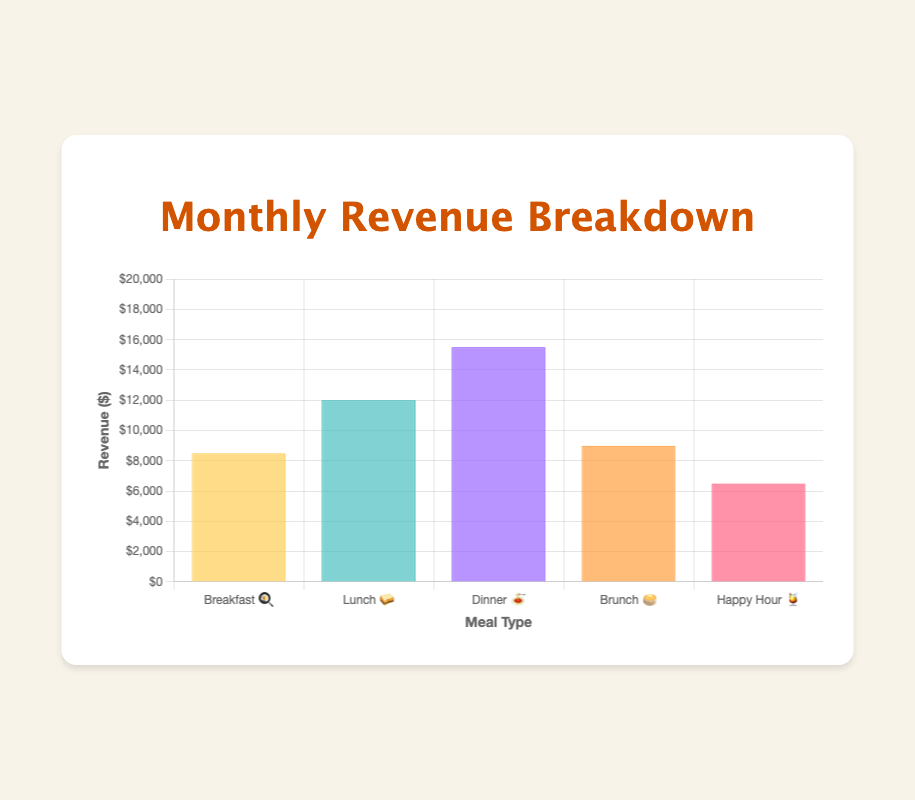What is the title of the chart? The title is at the top of the chart, and it states the main subject of the visualization.
Answer: Monthly Revenue Breakdown Which meal type generates the highest revenue? By looking at the height of the bars, the "Dinner 🍝" bar is the tallest.
Answer: Dinner 🍝 What is the total revenue from Breakfast 🍳 and Brunch 🥞 combined? Add the revenue from Breakfast 🍳 ($8500) and Brunch 🥞 ($9000): $8500 + $9000 = $17500
Answer: $17500 What is the difference in revenue between Lunch 🥪 and Happy Hour 🍹? Subtract the revenue of Happy Hour 🍹 ($6500) from Lunch 🥪 ($12000): $12000 - $6500 = $5500
Answer: $5500 Which meal type has the lowest revenue? The shortest bar represents the meal type with the lowest revenue, which is "Happy Hour 🍹".
Answer: Happy Hour 🍹 How much more revenue does Dinner 🍝 generate compared to Breakfast 🍳? Subtract the revenue of Breakfast 🍳 ($8500) from Dinner 🍝 ($15500): $15500 - $8500 = $7000
Answer: $7000 How does Brunch 🥞 revenue compare to Lunch 🥪 revenue? Brunch 🥞 revenue ($9000) is lower than Lunch 🥪 revenue ($12000) by comparing the heights of the bars.
Answer: Less What is the range of revenues across all meal types? The range is the difference between the highest revenue (Dinner 🍝, $15500) and the lowest revenue (Happy Hour 🍹, $6500): $15500 - $6500 = $9000
Answer: $9000 If the total monthly revenue target is $50000, how much more revenue is needed? Calculate the total revenue from all meal types and subtract from $50000: ($8500 + $12000 + $15500 + $9000 + $6500) = $51500. Target is already surpassed.
Answer: $0 